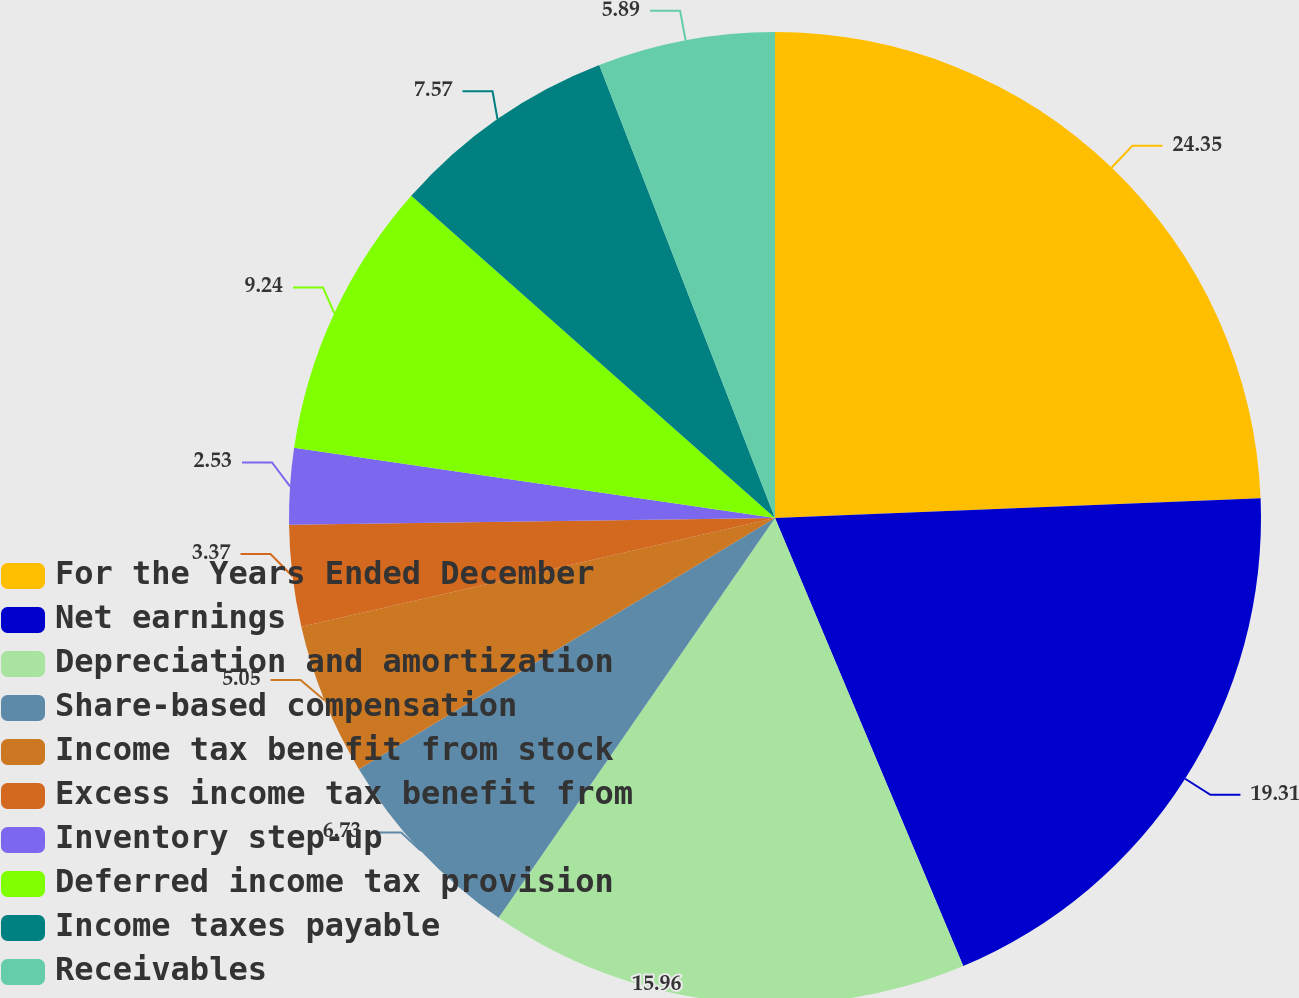Convert chart. <chart><loc_0><loc_0><loc_500><loc_500><pie_chart><fcel>For the Years Ended December<fcel>Net earnings<fcel>Depreciation and amortization<fcel>Share-based compensation<fcel>Income tax benefit from stock<fcel>Excess income tax benefit from<fcel>Inventory step-up<fcel>Deferred income tax provision<fcel>Income taxes payable<fcel>Receivables<nl><fcel>24.36%<fcel>19.32%<fcel>15.96%<fcel>6.73%<fcel>5.05%<fcel>3.37%<fcel>2.53%<fcel>9.24%<fcel>7.57%<fcel>5.89%<nl></chart> 